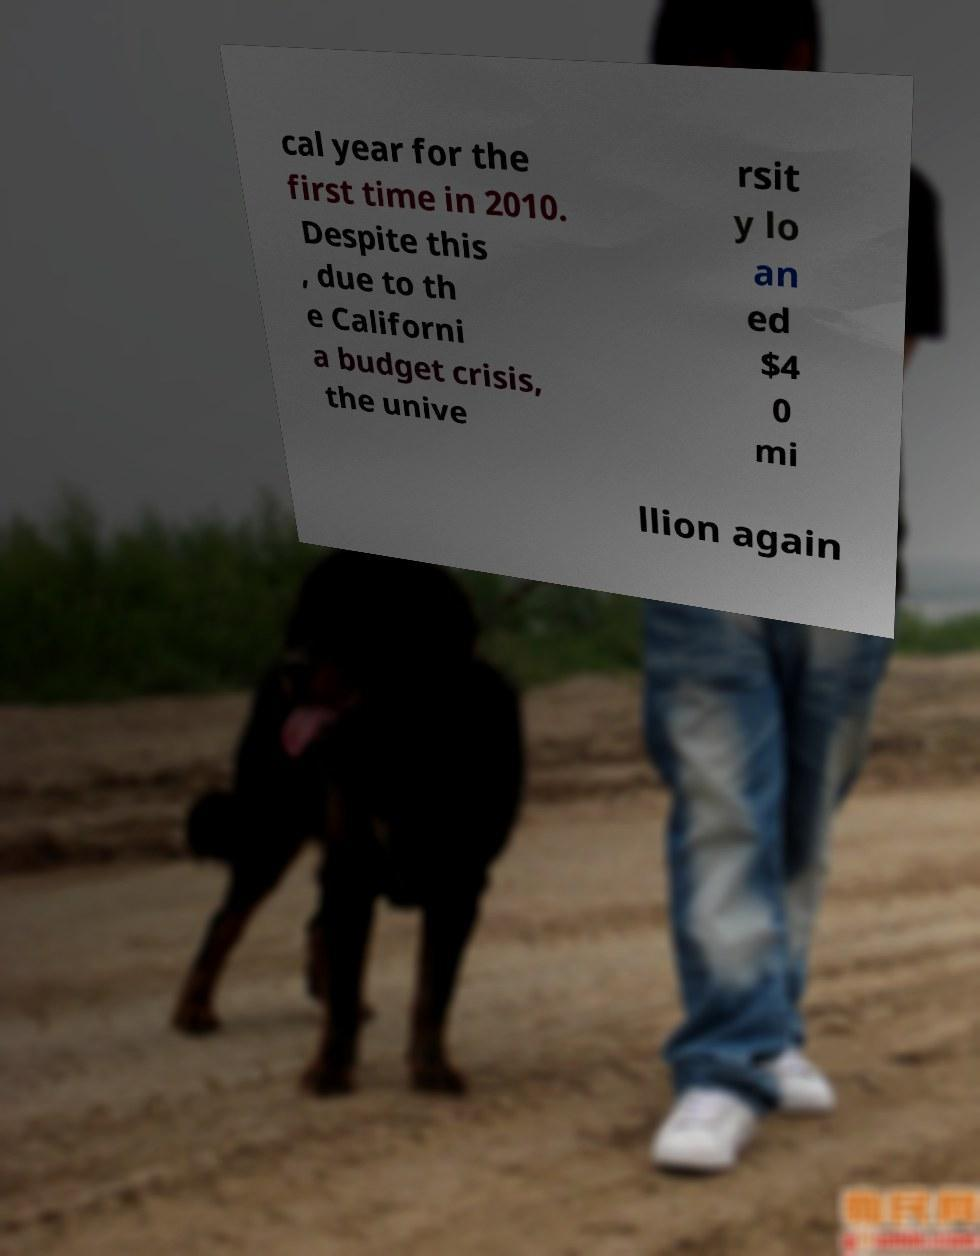Could you assist in decoding the text presented in this image and type it out clearly? cal year for the first time in 2010. Despite this , due to th e Californi a budget crisis, the unive rsit y lo an ed $4 0 mi llion again 